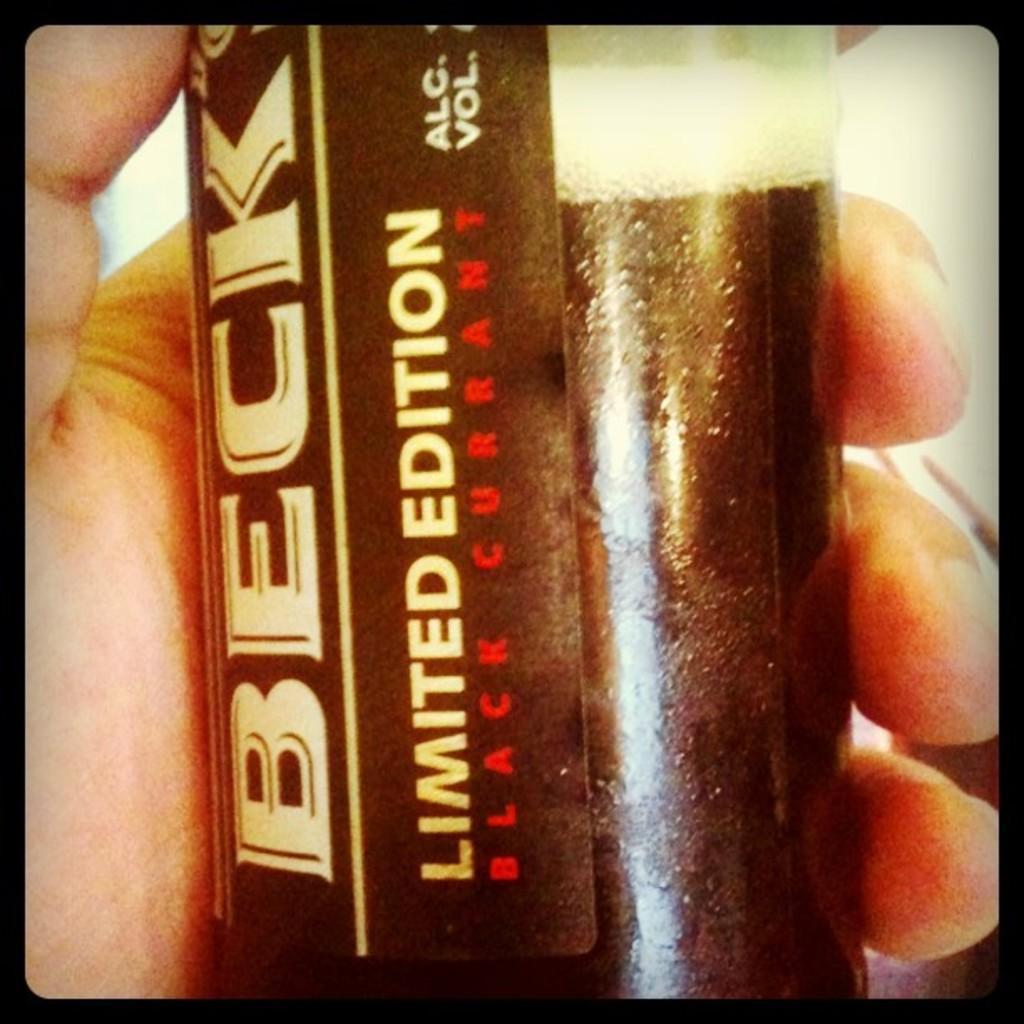How would you summarize this image in a sentence or two? In this picture i can see a person's hand who is holding a coke bottle. In that bottle there is a company sticker. 